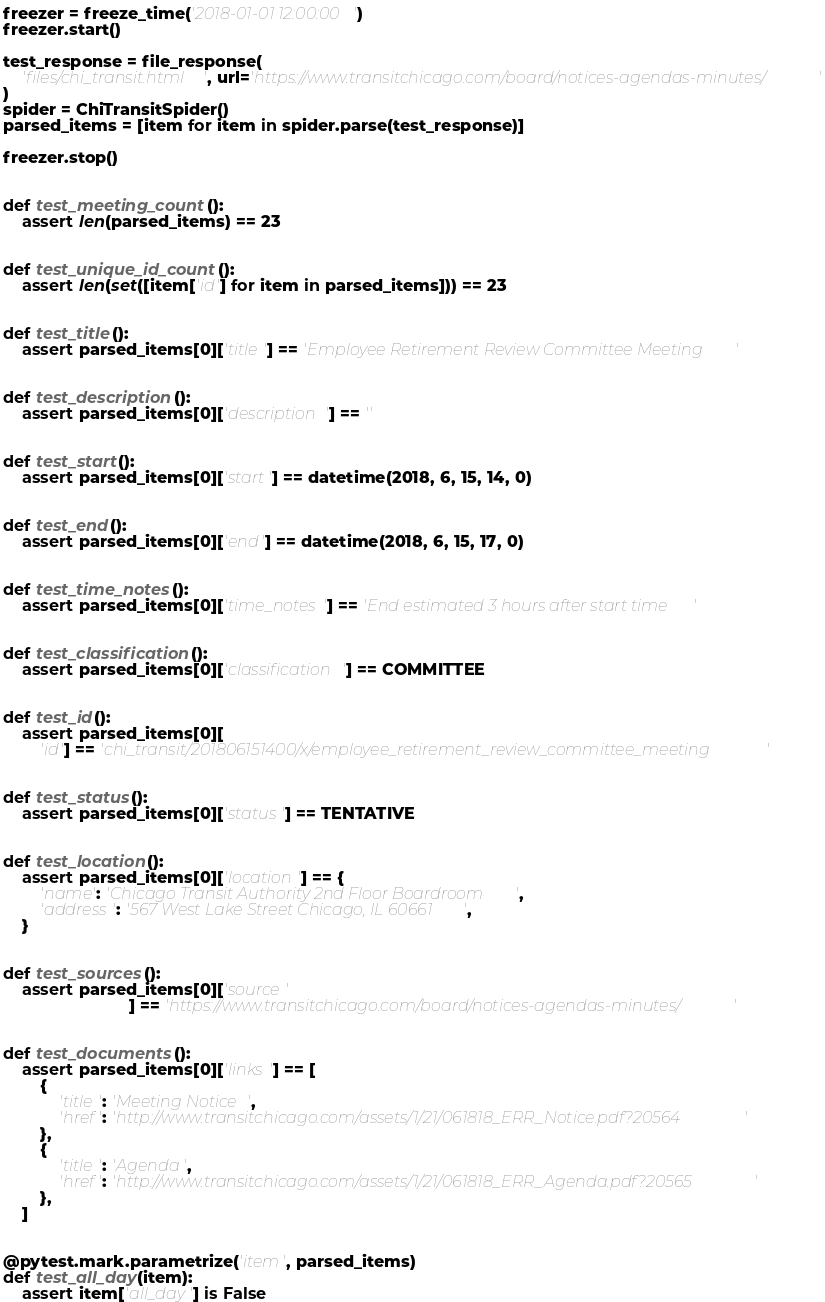<code> <loc_0><loc_0><loc_500><loc_500><_Python_>freezer = freeze_time('2018-01-01 12:00:00')
freezer.start()

test_response = file_response(
    'files/chi_transit.html', url='https://www.transitchicago.com/board/notices-agendas-minutes/'
)
spider = ChiTransitSpider()
parsed_items = [item for item in spider.parse(test_response)]

freezer.stop()


def test_meeting_count():
    assert len(parsed_items) == 23


def test_unique_id_count():
    assert len(set([item['id'] for item in parsed_items])) == 23


def test_title():
    assert parsed_items[0]['title'] == 'Employee Retirement Review Committee Meeting'


def test_description():
    assert parsed_items[0]['description'] == ''


def test_start():
    assert parsed_items[0]['start'] == datetime(2018, 6, 15, 14, 0)


def test_end():
    assert parsed_items[0]['end'] == datetime(2018, 6, 15, 17, 0)


def test_time_notes():
    assert parsed_items[0]['time_notes'] == 'End estimated 3 hours after start time'


def test_classification():
    assert parsed_items[0]['classification'] == COMMITTEE


def test_id():
    assert parsed_items[0][
        'id'] == 'chi_transit/201806151400/x/employee_retirement_review_committee_meeting'


def test_status():
    assert parsed_items[0]['status'] == TENTATIVE


def test_location():
    assert parsed_items[0]['location'] == {
        'name': 'Chicago Transit Authority 2nd Floor Boardroom',
        'address': '567 West Lake Street Chicago, IL 60661',
    }


def test_sources():
    assert parsed_items[0]['source'
                           ] == 'https://www.transitchicago.com/board/notices-agendas-minutes/'


def test_documents():
    assert parsed_items[0]['links'] == [
        {
            'title': 'Meeting Notice',
            'href': 'http://www.transitchicago.com/assets/1/21/061818_ERR_Notice.pdf?20564'
        },
        {
            'title': 'Agenda',
            'href': 'http://www.transitchicago.com/assets/1/21/061818_ERR_Agenda.pdf?20565'
        },
    ]


@pytest.mark.parametrize('item', parsed_items)
def test_all_day(item):
    assert item['all_day'] is False
</code> 